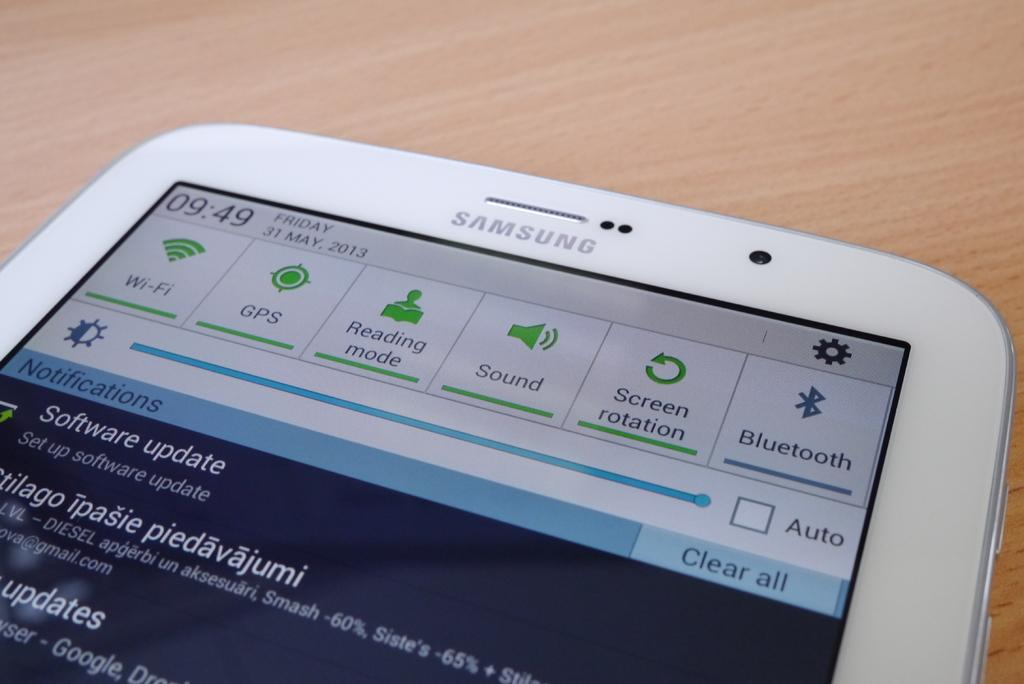Provide a one-sentence caption for the provided image. A white phone with a settings screen showing is a Samsung brand phone. 